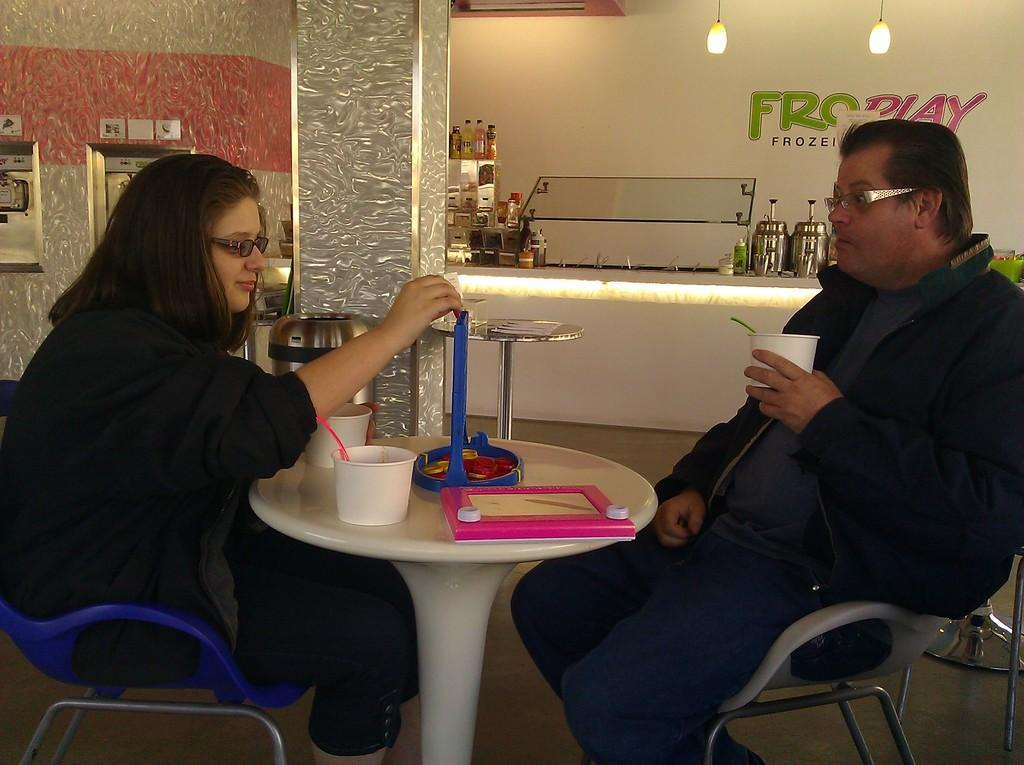How many people are sitting in the chairs in the image? There are two people sitting in chairs in the image. What is in front of the people? There is a table in front of the people. What can be found on the table? The table contains a blue toy. What colors are present in the background of the image? The background has white and pink colors. Is the room in the image completely quiet? The provided facts do not mention the level of noise in the room, so it cannot be determined if the room is completely quiet. 